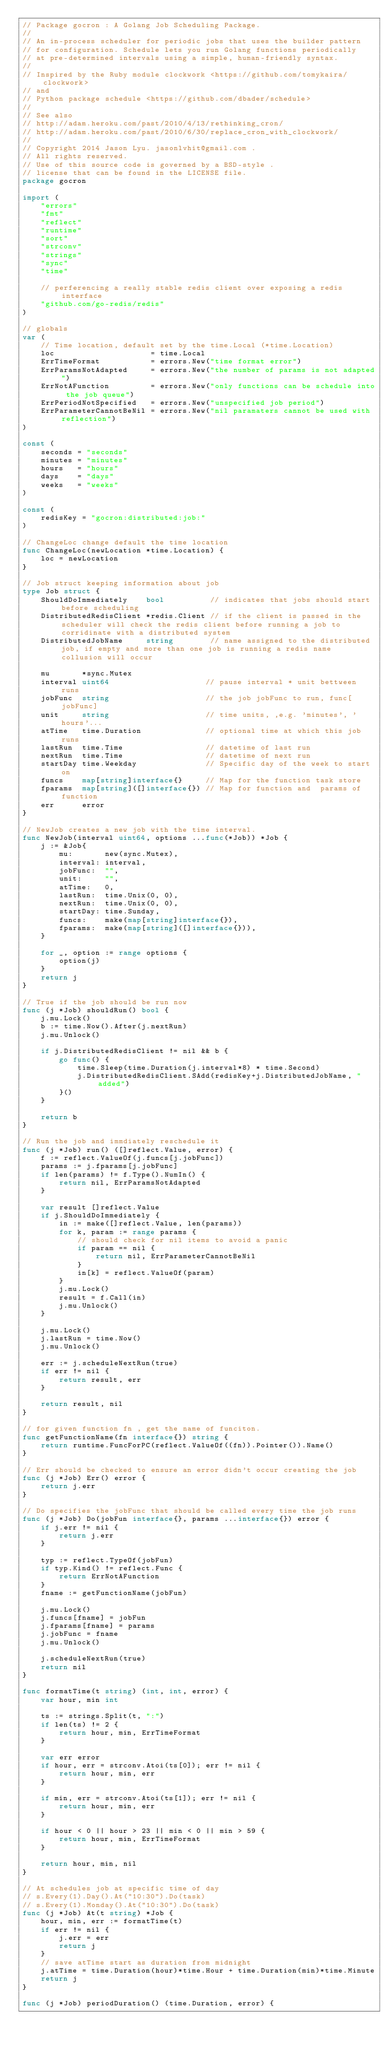Convert code to text. <code><loc_0><loc_0><loc_500><loc_500><_Go_>// Package gocron : A Golang Job Scheduling Package.
//
// An in-process scheduler for periodic jobs that uses the builder pattern
// for configuration. Schedule lets you run Golang functions periodically
// at pre-determined intervals using a simple, human-friendly syntax.
//
// Inspired by the Ruby module clockwork <https://github.com/tomykaira/clockwork>
// and
// Python package schedule <https://github.com/dbader/schedule>
//
// See also
// http://adam.heroku.com/past/2010/4/13/rethinking_cron/
// http://adam.heroku.com/past/2010/6/30/replace_cron_with_clockwork/
//
// Copyright 2014 Jason Lyu. jasonlvhit@gmail.com .
// All rights reserved.
// Use of this source code is governed by a BSD-style .
// license that can be found in the LICENSE file.
package gocron

import (
	"errors"
	"fmt"
	"reflect"
	"runtime"
	"sort"
	"strconv"
	"strings"
	"sync"
	"time"

	// perferencing a really stable redis client over exposing a redis interface
	"github.com/go-redis/redis"
)

// globals
var (
	// Time location, default set by the time.Local (*time.Location)
	loc                     = time.Local
	ErrTimeFormat           = errors.New("time format error")
	ErrParamsNotAdapted     = errors.New("the number of params is not adapted")
	ErrNotAFunction         = errors.New("only functions can be schedule into the job queue")
	ErrPeriodNotSpecified   = errors.New("unspecified job period")
	ErrParameterCannotBeNil = errors.New("nil paramaters cannot be used with reflection")
)

const (
	seconds = "seconds"
	minutes = "minutes"
	hours   = "hours"
	days    = "days"
	weeks   = "weeks"
)

const (
	redisKey = "gocron:distributed:job:"
)

// ChangeLoc change default the time location
func ChangeLoc(newLocation *time.Location) {
	loc = newLocation
}

// Job struct keeping information about job
type Job struct {
	ShouldDoImmediately    bool          // indicates that jobs should start before scheduling
	DistributedRedisClient *redis.Client // if the client is passed in the scheduler will check the redis client before running a job to corridinate with a distributed system
	DistributedJobName     string        // name assigned to the distributed job, if empty and more than one job is running a redis name collusion will occur

	mu       *sync.Mutex
	interval uint64                     // pause interval * unit bettween runs
	jobFunc  string                     // the job jobFunc to run, func[jobFunc]
	unit     string                     // time units, ,e.g. 'minutes', 'hours'...
	atTime   time.Duration              // optional time at which this job runs
	lastRun  time.Time                  // datetime of last run
	nextRun  time.Time                  // datetime of next run
	startDay time.Weekday               // Specific day of the week to start on
	funcs    map[string]interface{}     // Map for the function task store
	fparams  map[string]([]interface{}) // Map for function and  params of function
	err      error
}

// NewJob creates a new job with the time interval.
func NewJob(interval uint64, options ...func(*Job)) *Job {
	j := &Job{
		mu:       new(sync.Mutex),
		interval: interval,
		jobFunc:  "",
		unit:     "",
		atTime:   0,
		lastRun:  time.Unix(0, 0),
		nextRun:  time.Unix(0, 0),
		startDay: time.Sunday,
		funcs:    make(map[string]interface{}),
		fparams:  make(map[string]([]interface{})),
	}

	for _, option := range options {
		option(j)
	}
	return j
}

// True if the job should be run now
func (j *Job) shouldRun() bool {
	j.mu.Lock()
	b := time.Now().After(j.nextRun)
	j.mu.Unlock()

	if j.DistributedRedisClient != nil && b {
		go func() {
			time.Sleep(time.Duration(j.interval*8) * time.Second)
			j.DistributedRedisClient.SAdd(redisKey+j.DistributedJobName, "added")
		}()
	}

	return b
}

// Run the job and immdiately reschedule it
func (j *Job) run() ([]reflect.Value, error) {
	f := reflect.ValueOf(j.funcs[j.jobFunc])
	params := j.fparams[j.jobFunc]
	if len(params) != f.Type().NumIn() {
		return nil, ErrParamsNotAdapted
	}

	var result []reflect.Value
	if j.ShouldDoImmediately {
		in := make([]reflect.Value, len(params))
		for k, param := range params {
			// should check for nil items to avoid a panic
			if param == nil {
				return nil, ErrParameterCannotBeNil
			}
			in[k] = reflect.ValueOf(param)
		}
		j.mu.Lock()
		result = f.Call(in)
		j.mu.Unlock()
	}

	j.mu.Lock()
	j.lastRun = time.Now()
	j.mu.Unlock()

	err := j.scheduleNextRun(true)
	if err != nil {
		return result, err
	}

	return result, nil
}

// for given function fn , get the name of funciton.
func getFunctionName(fn interface{}) string {
	return runtime.FuncForPC(reflect.ValueOf((fn)).Pointer()).Name()
}

// Err should be checked to ensure an error didn't occur creating the job
func (j *Job) Err() error {
	return j.err
}

// Do specifies the jobFunc that should be called every time the job runs
func (j *Job) Do(jobFun interface{}, params ...interface{}) error {
	if j.err != nil {
		return j.err
	}

	typ := reflect.TypeOf(jobFun)
	if typ.Kind() != reflect.Func {
		return ErrNotAFunction
	}
	fname := getFunctionName(jobFun)

	j.mu.Lock()
	j.funcs[fname] = jobFun
	j.fparams[fname] = params
	j.jobFunc = fname
	j.mu.Unlock()

	j.scheduleNextRun(true)
	return nil
}

func formatTime(t string) (int, int, error) {
	var hour, min int

	ts := strings.Split(t, ":")
	if len(ts) != 2 {
		return hour, min, ErrTimeFormat
	}

	var err error
	if hour, err = strconv.Atoi(ts[0]); err != nil {
		return hour, min, err
	}

	if min, err = strconv.Atoi(ts[1]); err != nil {
		return hour, min, err
	}

	if hour < 0 || hour > 23 || min < 0 || min > 59 {
		return hour, min, ErrTimeFormat
	}

	return hour, min, nil
}

// At schedules job at specific time of day
// s.Every(1).Day().At("10:30").Do(task)
// s.Every(1).Monday().At("10:30").Do(task)
func (j *Job) At(t string) *Job {
	hour, min, err := formatTime(t)
	if err != nil {
		j.err = err
		return j
	}
	// save atTime start as duration from midnight
	j.atTime = time.Duration(hour)*time.Hour + time.Duration(min)*time.Minute
	return j
}

func (j *Job) periodDuration() (time.Duration, error) {</code> 